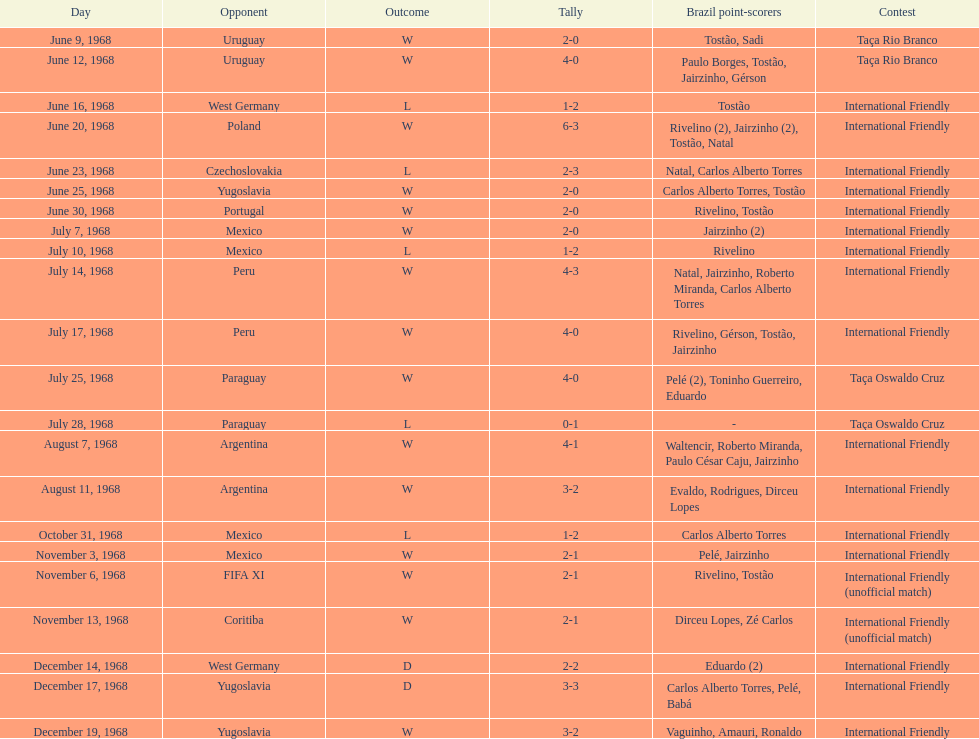The most goals scored by brazil in a game 6. Could you parse the entire table? {'header': ['Day', 'Opponent', 'Outcome', 'Tally', 'Brazil point-scorers', 'Contest'], 'rows': [['June 9, 1968', 'Uruguay', 'W', '2-0', 'Tostão, Sadi', 'Taça Rio Branco'], ['June 12, 1968', 'Uruguay', 'W', '4-0', 'Paulo Borges, Tostão, Jairzinho, Gérson', 'Taça Rio Branco'], ['June 16, 1968', 'West Germany', 'L', '1-2', 'Tostão', 'International Friendly'], ['June 20, 1968', 'Poland', 'W', '6-3', 'Rivelino (2), Jairzinho (2), Tostão, Natal', 'International Friendly'], ['June 23, 1968', 'Czechoslovakia', 'L', '2-3', 'Natal, Carlos Alberto Torres', 'International Friendly'], ['June 25, 1968', 'Yugoslavia', 'W', '2-0', 'Carlos Alberto Torres, Tostão', 'International Friendly'], ['June 30, 1968', 'Portugal', 'W', '2-0', 'Rivelino, Tostão', 'International Friendly'], ['July 7, 1968', 'Mexico', 'W', '2-0', 'Jairzinho (2)', 'International Friendly'], ['July 10, 1968', 'Mexico', 'L', '1-2', 'Rivelino', 'International Friendly'], ['July 14, 1968', 'Peru', 'W', '4-3', 'Natal, Jairzinho, Roberto Miranda, Carlos Alberto Torres', 'International Friendly'], ['July 17, 1968', 'Peru', 'W', '4-0', 'Rivelino, Gérson, Tostão, Jairzinho', 'International Friendly'], ['July 25, 1968', 'Paraguay', 'W', '4-0', 'Pelé (2), Toninho Guerreiro, Eduardo', 'Taça Oswaldo Cruz'], ['July 28, 1968', 'Paraguay', 'L', '0-1', '-', 'Taça Oswaldo Cruz'], ['August 7, 1968', 'Argentina', 'W', '4-1', 'Waltencir, Roberto Miranda, Paulo César Caju, Jairzinho', 'International Friendly'], ['August 11, 1968', 'Argentina', 'W', '3-2', 'Evaldo, Rodrigues, Dirceu Lopes', 'International Friendly'], ['October 31, 1968', 'Mexico', 'L', '1-2', 'Carlos Alberto Torres', 'International Friendly'], ['November 3, 1968', 'Mexico', 'W', '2-1', 'Pelé, Jairzinho', 'International Friendly'], ['November 6, 1968', 'FIFA XI', 'W', '2-1', 'Rivelino, Tostão', 'International Friendly (unofficial match)'], ['November 13, 1968', 'Coritiba', 'W', '2-1', 'Dirceu Lopes, Zé Carlos', 'International Friendly (unofficial match)'], ['December 14, 1968', 'West Germany', 'D', '2-2', 'Eduardo (2)', 'International Friendly'], ['December 17, 1968', 'Yugoslavia', 'D', '3-3', 'Carlos Alberto Torres, Pelé, Babá', 'International Friendly'], ['December 19, 1968', 'Yugoslavia', 'W', '3-2', 'Vaguinho, Amauri, Ronaldo', 'International Friendly']]} 